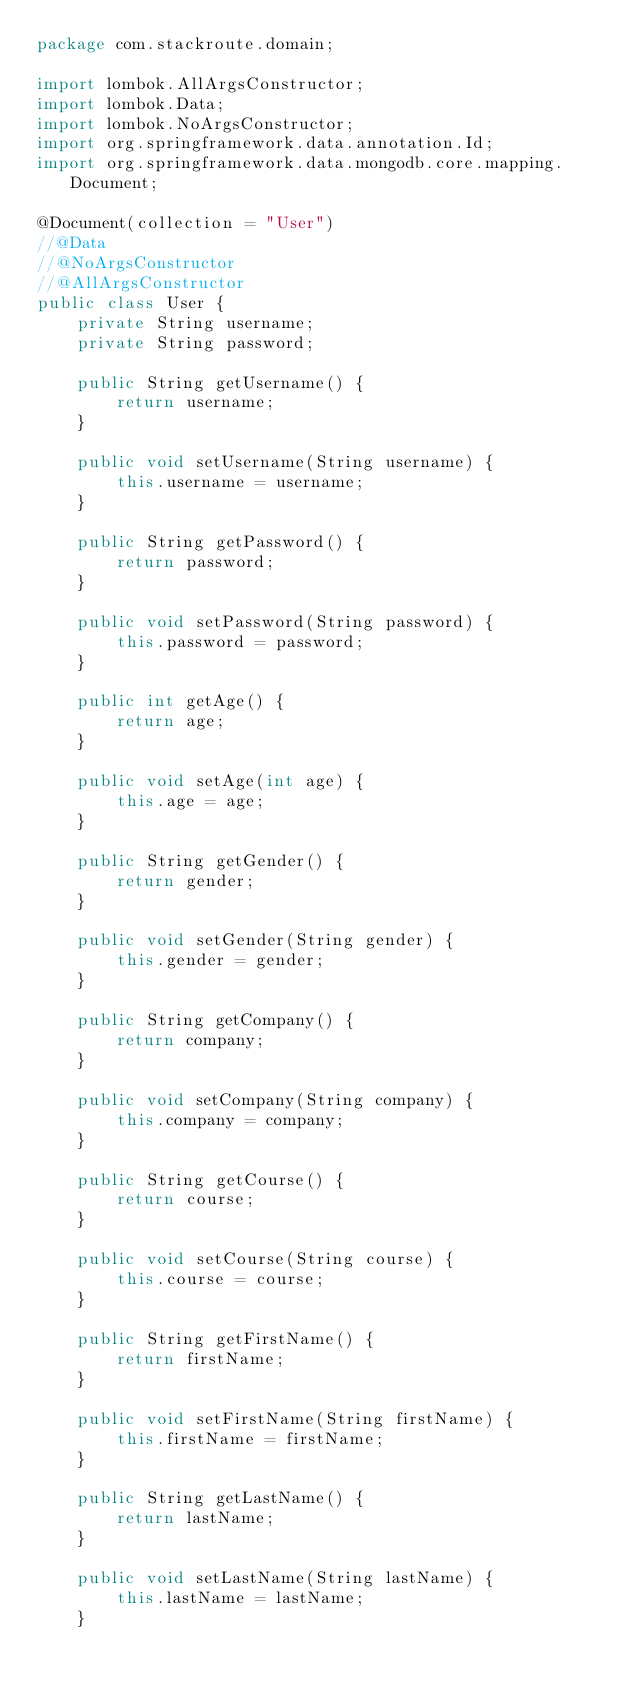Convert code to text. <code><loc_0><loc_0><loc_500><loc_500><_Java_>package com.stackroute.domain;

import lombok.AllArgsConstructor;
import lombok.Data;
import lombok.NoArgsConstructor;
import org.springframework.data.annotation.Id;
import org.springframework.data.mongodb.core.mapping.Document;

@Document(collection = "User")
//@Data
//@NoArgsConstructor
//@AllArgsConstructor
public class User {
    private String username;
    private String password;

    public String getUsername() {
        return username;
    }

    public void setUsername(String username) {
        this.username = username;
    }

    public String getPassword() {
        return password;
    }

    public void setPassword(String password) {
        this.password = password;
    }

    public int getAge() {
        return age;
    }

    public void setAge(int age) {
        this.age = age;
    }

    public String getGender() {
        return gender;
    }

    public void setGender(String gender) {
        this.gender = gender;
    }

    public String getCompany() {
        return company;
    }

    public void setCompany(String company) {
        this.company = company;
    }

    public String getCourse() {
        return course;
    }

    public void setCourse(String course) {
        this.course = course;
    }

    public String getFirstName() {
        return firstName;
    }

    public void setFirstName(String firstName) {
        this.firstName = firstName;
    }

    public String getLastName() {
        return lastName;
    }

    public void setLastName(String lastName) {
        this.lastName = lastName;
    }
</code> 